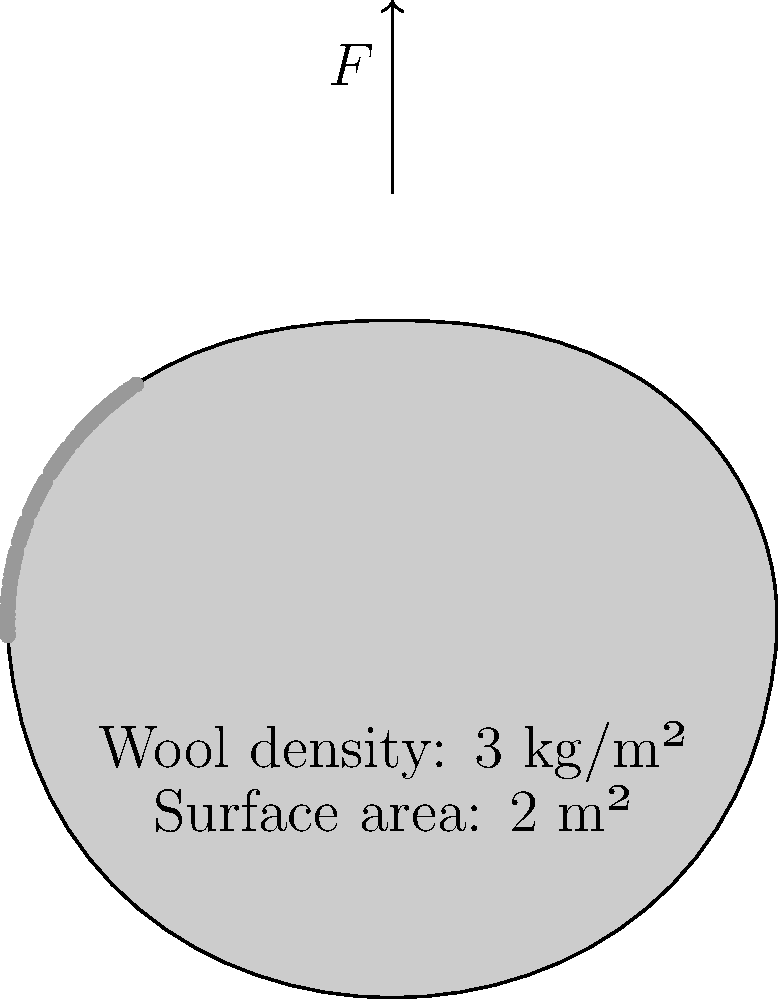As a boutique shepherd, you're preparing to shear your prized sheep. Given that the wool density is 3 kg/m² and the surface area of the sheep is 2 m², calculate the minimum force required to shear the sheep if the coefficient of friction between the shears and the wool is 0.4. Assume the acceleration due to gravity is 9.8 m/s². To solve this problem, we'll follow these steps:

1. Calculate the total mass of wool:
   Mass = Density × Area
   $m = 3 \text{ kg/m²} \times 2 \text{ m²} = 6 \text{ kg}$

2. Calculate the normal force, which is equal to the weight of the wool:
   $F_N = mg = 6 \text{ kg} \times 9.8 \text{ m/s²} = 58.8 \text{ N}$

3. Use the coefficient of friction to determine the force required:
   $F = \mu F_N$
   Where $\mu$ is the coefficient of friction

4. Substitute the values:
   $F = 0.4 \times 58.8 \text{ N} = 23.52 \text{ N}$

Therefore, the minimum force required to shear the sheep is 23.52 N.
Answer: 23.52 N 